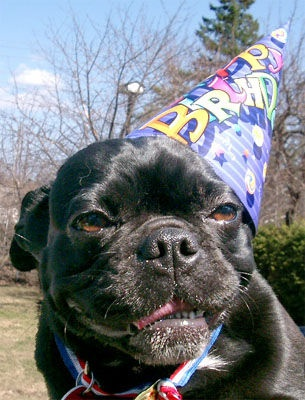Describe the objects in this image and their specific colors. I can see a dog in lightblue, black, gray, and darkgray tones in this image. 